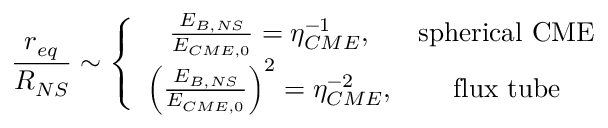<formula> <loc_0><loc_0><loc_500><loc_500>\frac { r _ { e q } } { R _ { N S } } \sim \left \{ \begin{array} { c c } { \frac { E _ { B , N S } } { E _ { C M E , 0 } } = \eta _ { C M E } ^ { - 1 } , } & { s p h e r i c a l C M E } \\ { \left ( \frac { E _ { B , N S } } { E _ { C M E , 0 } } \right ) ^ { 2 } = \eta _ { C M E } ^ { - 2 } , } & { f l u x t u b e } \end{array}</formula> 